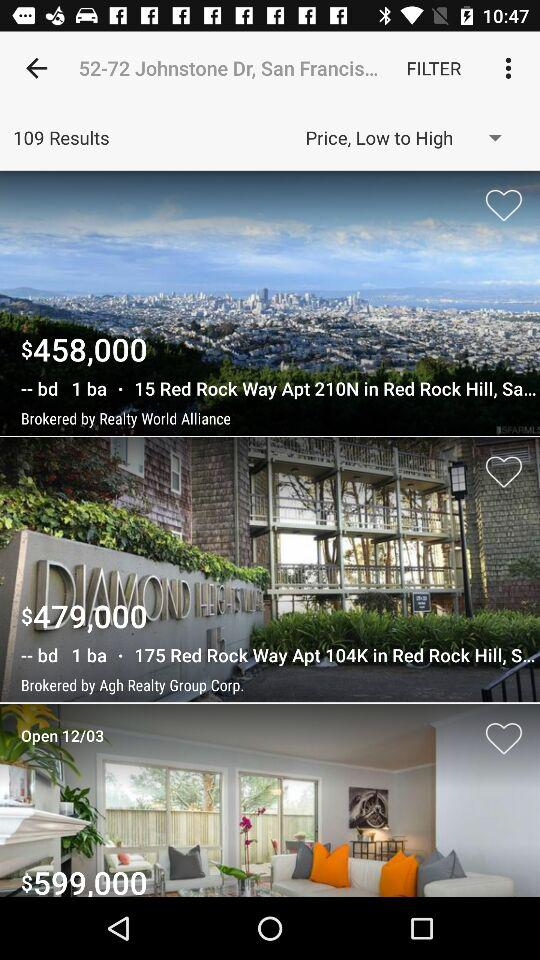What is the cost of 15 Red Rock Way Apartment 210N in Red Rock Hill? The cost of 15 Red Rock Way Apartment 210N in Red Rock Hill is $458,000. 